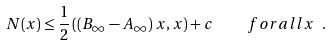Convert formula to latex. <formula><loc_0><loc_0><loc_500><loc_500>N ( x ) \leq \frac { 1 } { 2 } \left ( \left ( B _ { \infty } - A _ { \infty } \right ) x , x \right ) + c \quad f o r a l l x \ .</formula> 